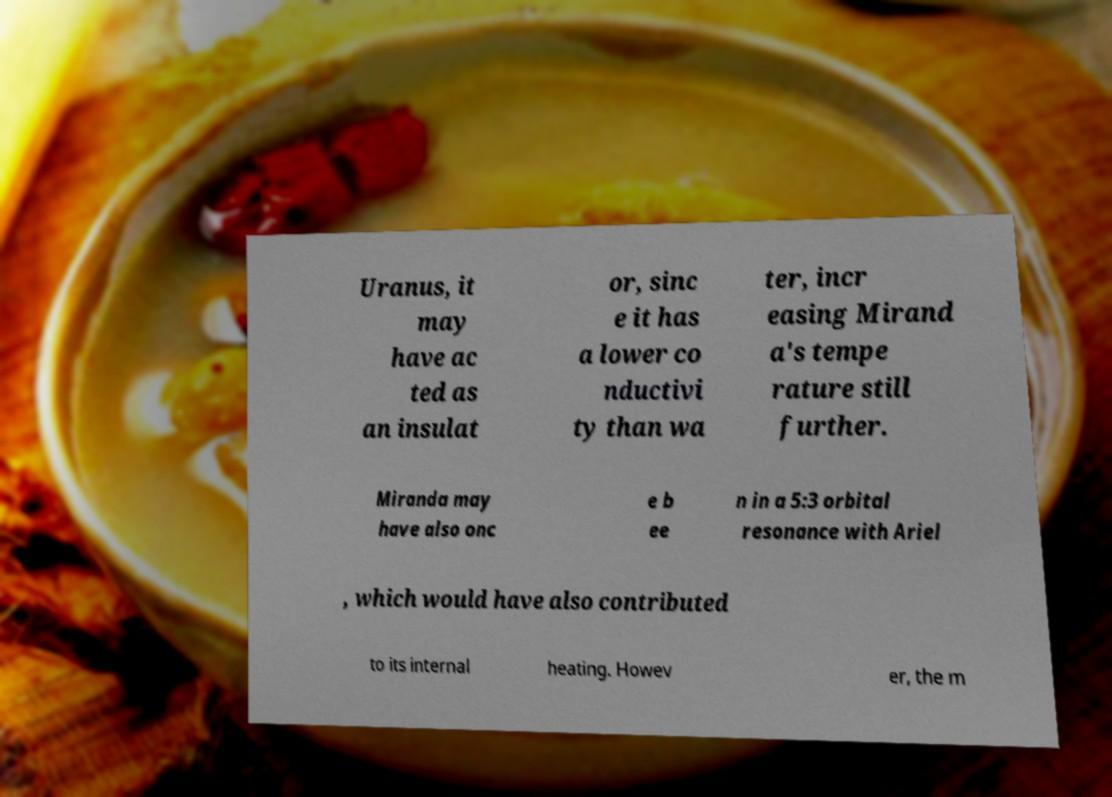Could you assist in decoding the text presented in this image and type it out clearly? Uranus, it may have ac ted as an insulat or, sinc e it has a lower co nductivi ty than wa ter, incr easing Mirand a's tempe rature still further. Miranda may have also onc e b ee n in a 5:3 orbital resonance with Ariel , which would have also contributed to its internal heating. Howev er, the m 